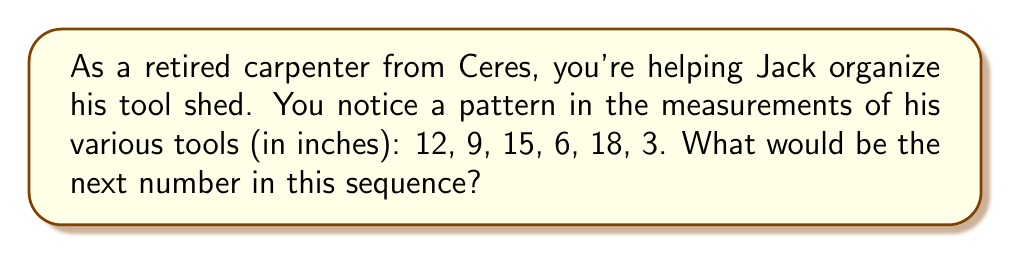Help me with this question. Let's analyze this sequence step-by-step:

1) First, let's look at the alternating pattern:
   12, 9, 15, 6, 18, 3

2) We can split this into two sub-sequences:
   Odd positions: 12, 15, 18
   Even positions: 9, 6, 3

3) For the odd positions:
   12 → 15 → 18
   The pattern is adding 3 each time: $12 + 3 = 15$, $15 + 3 = 18$

4) For the even positions:
   9 → 6 → 3
   The pattern is subtracting 3 each time: $9 - 3 = 6$, $6 - 3 = 3$

5) The next term would be in an odd position, continuing the first sub-sequence.

6) Following the pattern of adding 3:
   $18 + 3 = 21$

Therefore, the next number in the sequence would be 21.
Answer: 21 